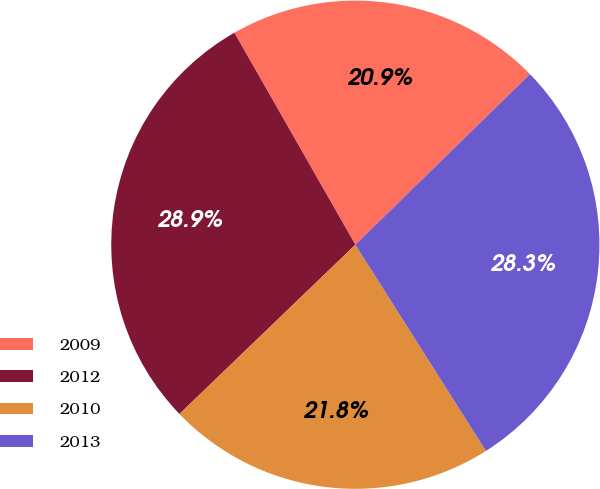<chart> <loc_0><loc_0><loc_500><loc_500><pie_chart><fcel>2009<fcel>2012<fcel>2010<fcel>2013<nl><fcel>20.94%<fcel>28.94%<fcel>21.79%<fcel>28.33%<nl></chart> 